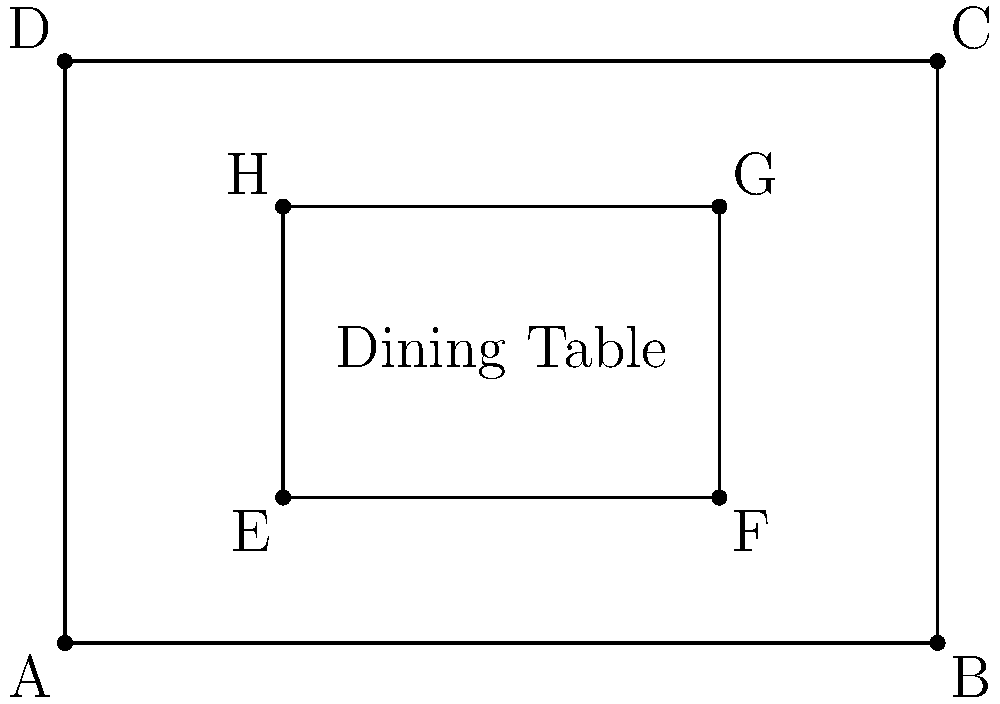In a traditional 18th-century dining room, a rectangular table is placed centrally in a rectangular room. The room measures 6 units by 4 units, while the table measures 3 units by 2 units. If the table is positioned symmetrically in the room, what is the ratio of the area of the empty space around the table to the area of the table itself? To solve this problem, we'll follow these steps:

1. Calculate the area of the room:
   $A_{room} = 6 \times 4 = 24$ square units

2. Calculate the area of the table:
   $A_{table} = 3 \times 2 = 6$ square units

3. Calculate the empty space:
   $A_{empty} = A_{room} - A_{table} = 24 - 6 = 18$ square units

4. Find the ratio of empty space to table area:
   $\text{Ratio} = \frac{A_{empty}}{A_{table}} = \frac{18}{6} = 3:1$

This ratio can be simplified to 3:1, meaning for every 1 square unit of table space, there are 3 square units of empty space around it.

This layout reflects the importance of spaciousness and symmetry in 18th-century dining rooms, allowing for comfortable movement of servers and guests around the table during elaborate meals.
Answer: 3:1 